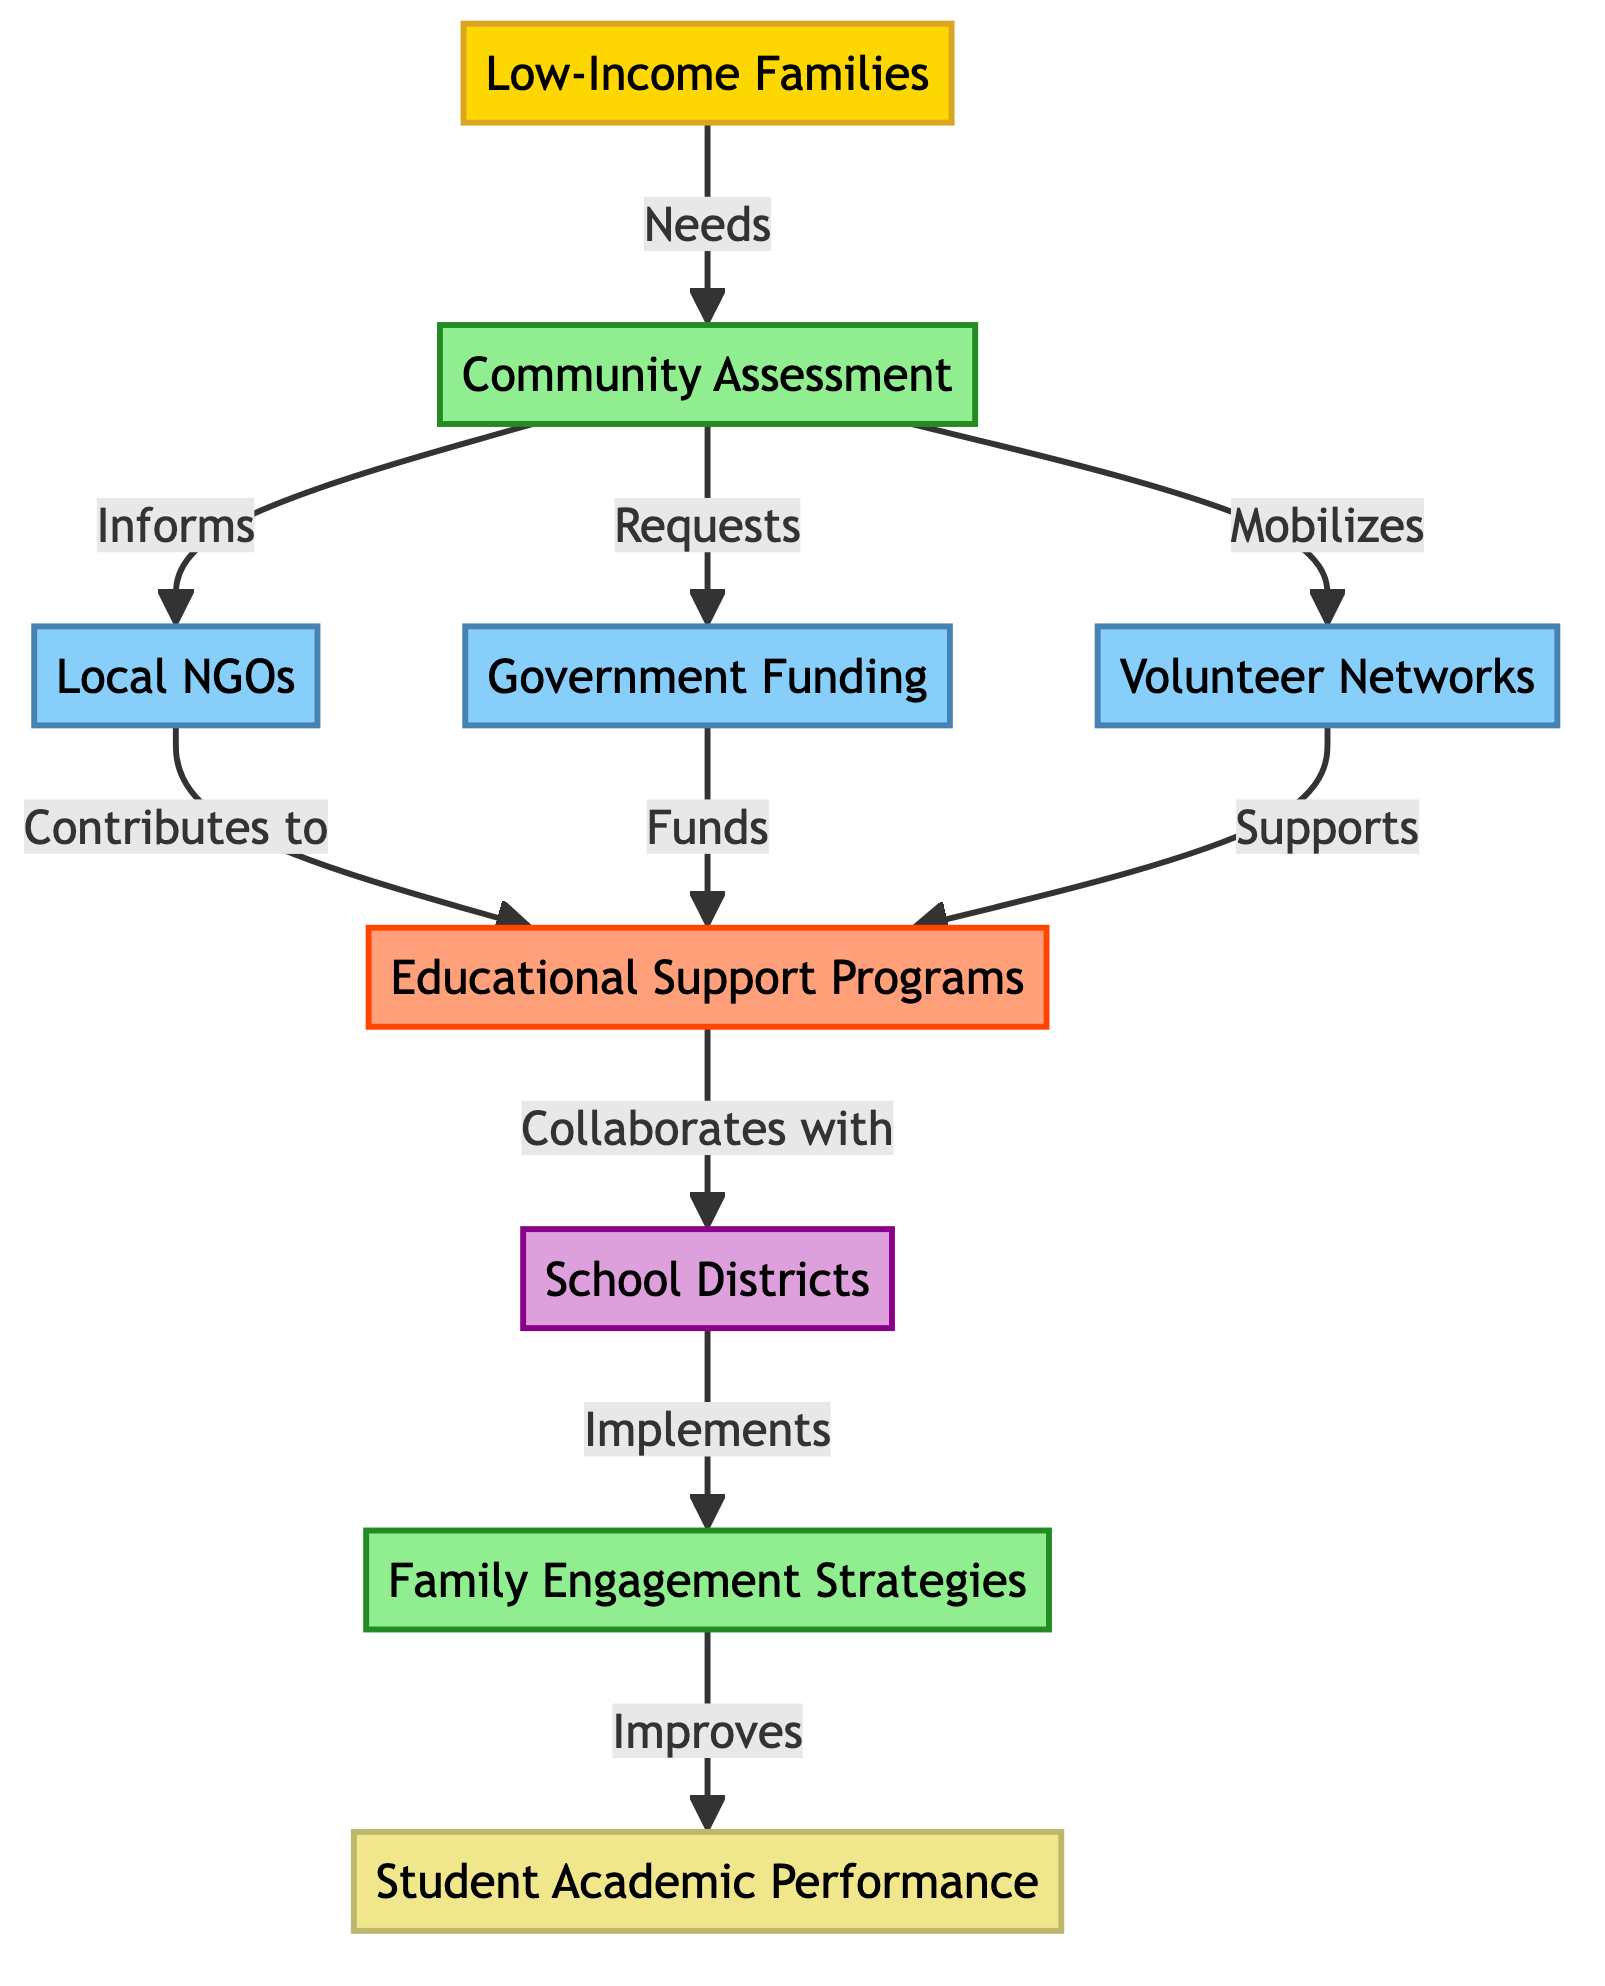What is the initial source of resources in the flow chart? The flow chart identifies "Low-Income Families" as the starting point or source that initiates the process.
Answer: Low-Income Families How many process nodes are present in the diagram? There are two process nodes: "Community Assessment" and "Family Engagement Strategies". Counted as 1 and 8 respectively.
Answer: 2 Which resource directly contributes to the "Educational Support Programs"? The resource "Local NGOs" contributes to "Educational Support Programs" as indicated by the connection from node 3 to node 5.
Answer: Local NGOs What relationship does "Community Assessment" have with "Government Funding"? "Community Assessment" requests "Government Funding" as indicated by the directed connection from node 2 to node 4 with the label "Requests".
Answer: Requests Which partner is involved in the implementation of family engagement strategies? The partner involved is "School Districts", as it is connected from the "Educational Support Programs" to "Family Engagement Strategies" indicating the implementation role.
Answer: School Districts How do "Volunteer Networks" support educational support programs? They support "Educational Support Programs" by directly contributing resources, as indicated by the connection between node 6 and node 5 labeled "Supports".
Answer: Supports What is the final outcome resulting from the family engagement strategies? The final outcome is "Student Academic Performance", as shown by the connection from node 8 to node 9 labeled "Improves".
Answer: Student Academic Performance Which node has the most incoming connections, and how many does it have? The "Educational Support Programs" node has three incoming connections: from "Local NGOs", "Government Funding", and "Volunteer Networks". Therefore, it has the most connections in this flow.
Answer: 3 What role does "Community Assessment" play in the overall flow of resources? "Community Assessment" serves as a critical process that informs other resources such as NGOs, requests funding, and mobilizes volunteer networks, facilitating the overall support for educational programs.
Answer: Process 